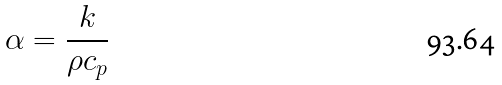<formula> <loc_0><loc_0><loc_500><loc_500>\alpha = \frac { k } { \rho c _ { p } }</formula> 